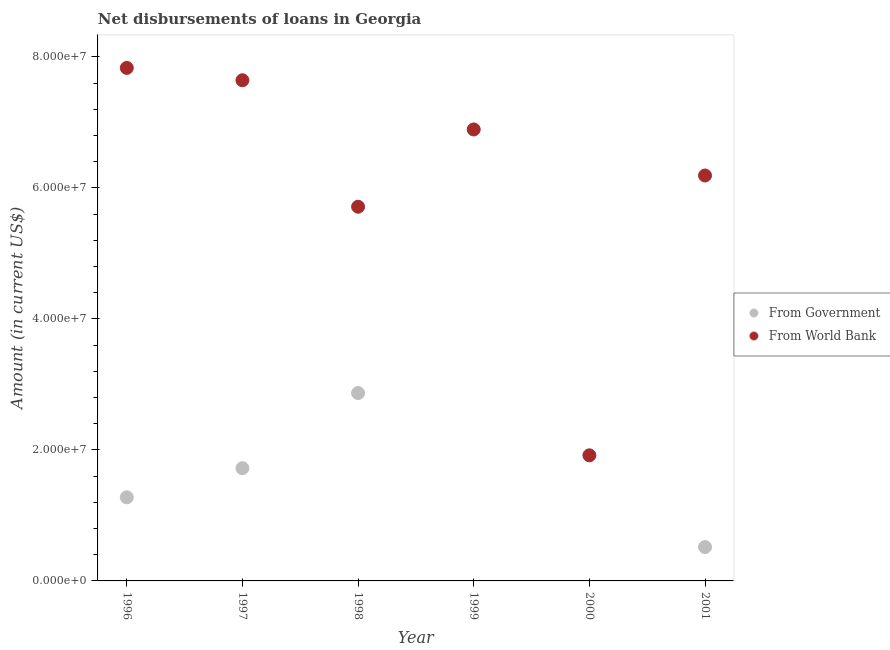How many different coloured dotlines are there?
Your answer should be compact. 2. Is the number of dotlines equal to the number of legend labels?
Offer a terse response. No. What is the net disbursements of loan from government in 1996?
Offer a terse response. 1.28e+07. Across all years, what is the maximum net disbursements of loan from government?
Offer a terse response. 2.87e+07. Across all years, what is the minimum net disbursements of loan from world bank?
Ensure brevity in your answer.  1.92e+07. What is the total net disbursements of loan from government in the graph?
Keep it short and to the point. 6.38e+07. What is the difference between the net disbursements of loan from world bank in 1996 and that in 2000?
Give a very brief answer. 5.91e+07. What is the difference between the net disbursements of loan from government in 1997 and the net disbursements of loan from world bank in 1996?
Provide a short and direct response. -6.11e+07. What is the average net disbursements of loan from world bank per year?
Keep it short and to the point. 6.03e+07. In the year 1998, what is the difference between the net disbursements of loan from world bank and net disbursements of loan from government?
Provide a succinct answer. 2.84e+07. In how many years, is the net disbursements of loan from government greater than 16000000 US$?
Ensure brevity in your answer.  2. What is the ratio of the net disbursements of loan from government in 1998 to that in 2001?
Make the answer very short. 5.55. What is the difference between the highest and the second highest net disbursements of loan from world bank?
Keep it short and to the point. 1.88e+06. What is the difference between the highest and the lowest net disbursements of loan from world bank?
Provide a succinct answer. 5.91e+07. Is the net disbursements of loan from government strictly greater than the net disbursements of loan from world bank over the years?
Ensure brevity in your answer.  No. Is the net disbursements of loan from government strictly less than the net disbursements of loan from world bank over the years?
Offer a terse response. Yes. How many years are there in the graph?
Provide a succinct answer. 6. Are the values on the major ticks of Y-axis written in scientific E-notation?
Give a very brief answer. Yes. What is the title of the graph?
Your answer should be very brief. Net disbursements of loans in Georgia. What is the label or title of the X-axis?
Your answer should be very brief. Year. What is the label or title of the Y-axis?
Your answer should be compact. Amount (in current US$). What is the Amount (in current US$) in From Government in 1996?
Provide a short and direct response. 1.28e+07. What is the Amount (in current US$) of From World Bank in 1996?
Your answer should be compact. 7.83e+07. What is the Amount (in current US$) in From Government in 1997?
Offer a terse response. 1.72e+07. What is the Amount (in current US$) of From World Bank in 1997?
Your response must be concise. 7.64e+07. What is the Amount (in current US$) in From Government in 1998?
Give a very brief answer. 2.87e+07. What is the Amount (in current US$) in From World Bank in 1998?
Offer a terse response. 5.71e+07. What is the Amount (in current US$) of From Government in 1999?
Give a very brief answer. 0. What is the Amount (in current US$) in From World Bank in 1999?
Offer a terse response. 6.89e+07. What is the Amount (in current US$) of From Government in 2000?
Offer a very short reply. 0. What is the Amount (in current US$) of From World Bank in 2000?
Offer a terse response. 1.92e+07. What is the Amount (in current US$) in From Government in 2001?
Offer a very short reply. 5.17e+06. What is the Amount (in current US$) in From World Bank in 2001?
Keep it short and to the point. 6.19e+07. Across all years, what is the maximum Amount (in current US$) of From Government?
Make the answer very short. 2.87e+07. Across all years, what is the maximum Amount (in current US$) of From World Bank?
Offer a very short reply. 7.83e+07. Across all years, what is the minimum Amount (in current US$) of From World Bank?
Keep it short and to the point. 1.92e+07. What is the total Amount (in current US$) in From Government in the graph?
Keep it short and to the point. 6.38e+07. What is the total Amount (in current US$) of From World Bank in the graph?
Provide a succinct answer. 3.62e+08. What is the difference between the Amount (in current US$) of From Government in 1996 and that in 1997?
Make the answer very short. -4.45e+06. What is the difference between the Amount (in current US$) of From World Bank in 1996 and that in 1997?
Provide a succinct answer. 1.88e+06. What is the difference between the Amount (in current US$) in From Government in 1996 and that in 1998?
Provide a succinct answer. -1.59e+07. What is the difference between the Amount (in current US$) of From World Bank in 1996 and that in 1998?
Give a very brief answer. 2.12e+07. What is the difference between the Amount (in current US$) in From World Bank in 1996 and that in 1999?
Your answer should be compact. 9.40e+06. What is the difference between the Amount (in current US$) in From World Bank in 1996 and that in 2000?
Keep it short and to the point. 5.91e+07. What is the difference between the Amount (in current US$) of From Government in 1996 and that in 2001?
Offer a terse response. 7.59e+06. What is the difference between the Amount (in current US$) of From World Bank in 1996 and that in 2001?
Keep it short and to the point. 1.64e+07. What is the difference between the Amount (in current US$) in From Government in 1997 and that in 1998?
Your response must be concise. -1.15e+07. What is the difference between the Amount (in current US$) in From World Bank in 1997 and that in 1998?
Make the answer very short. 1.93e+07. What is the difference between the Amount (in current US$) of From World Bank in 1997 and that in 1999?
Make the answer very short. 7.51e+06. What is the difference between the Amount (in current US$) in From World Bank in 1997 and that in 2000?
Give a very brief answer. 5.73e+07. What is the difference between the Amount (in current US$) of From Government in 1997 and that in 2001?
Give a very brief answer. 1.20e+07. What is the difference between the Amount (in current US$) in From World Bank in 1997 and that in 2001?
Provide a short and direct response. 1.45e+07. What is the difference between the Amount (in current US$) of From World Bank in 1998 and that in 1999?
Your response must be concise. -1.18e+07. What is the difference between the Amount (in current US$) of From World Bank in 1998 and that in 2000?
Ensure brevity in your answer.  3.80e+07. What is the difference between the Amount (in current US$) in From Government in 1998 and that in 2001?
Provide a short and direct response. 2.35e+07. What is the difference between the Amount (in current US$) in From World Bank in 1998 and that in 2001?
Make the answer very short. -4.77e+06. What is the difference between the Amount (in current US$) of From World Bank in 1999 and that in 2000?
Provide a short and direct response. 4.98e+07. What is the difference between the Amount (in current US$) in From World Bank in 1999 and that in 2001?
Offer a very short reply. 7.03e+06. What is the difference between the Amount (in current US$) in From World Bank in 2000 and that in 2001?
Keep it short and to the point. -4.27e+07. What is the difference between the Amount (in current US$) of From Government in 1996 and the Amount (in current US$) of From World Bank in 1997?
Ensure brevity in your answer.  -6.37e+07. What is the difference between the Amount (in current US$) in From Government in 1996 and the Amount (in current US$) in From World Bank in 1998?
Offer a very short reply. -4.44e+07. What is the difference between the Amount (in current US$) in From Government in 1996 and the Amount (in current US$) in From World Bank in 1999?
Provide a succinct answer. -5.62e+07. What is the difference between the Amount (in current US$) of From Government in 1996 and the Amount (in current US$) of From World Bank in 2000?
Your answer should be very brief. -6.42e+06. What is the difference between the Amount (in current US$) in From Government in 1996 and the Amount (in current US$) in From World Bank in 2001?
Give a very brief answer. -4.91e+07. What is the difference between the Amount (in current US$) of From Government in 1997 and the Amount (in current US$) of From World Bank in 1998?
Provide a succinct answer. -3.99e+07. What is the difference between the Amount (in current US$) in From Government in 1997 and the Amount (in current US$) in From World Bank in 1999?
Your response must be concise. -5.17e+07. What is the difference between the Amount (in current US$) in From Government in 1997 and the Amount (in current US$) in From World Bank in 2000?
Offer a very short reply. -1.96e+06. What is the difference between the Amount (in current US$) in From Government in 1997 and the Amount (in current US$) in From World Bank in 2001?
Your answer should be compact. -4.47e+07. What is the difference between the Amount (in current US$) of From Government in 1998 and the Amount (in current US$) of From World Bank in 1999?
Keep it short and to the point. -4.02e+07. What is the difference between the Amount (in current US$) in From Government in 1998 and the Amount (in current US$) in From World Bank in 2000?
Your answer should be compact. 9.51e+06. What is the difference between the Amount (in current US$) of From Government in 1998 and the Amount (in current US$) of From World Bank in 2001?
Provide a short and direct response. -3.32e+07. What is the average Amount (in current US$) of From Government per year?
Your response must be concise. 1.06e+07. What is the average Amount (in current US$) in From World Bank per year?
Ensure brevity in your answer.  6.03e+07. In the year 1996, what is the difference between the Amount (in current US$) of From Government and Amount (in current US$) of From World Bank?
Ensure brevity in your answer.  -6.56e+07. In the year 1997, what is the difference between the Amount (in current US$) of From Government and Amount (in current US$) of From World Bank?
Give a very brief answer. -5.92e+07. In the year 1998, what is the difference between the Amount (in current US$) in From Government and Amount (in current US$) in From World Bank?
Offer a terse response. -2.84e+07. In the year 2001, what is the difference between the Amount (in current US$) in From Government and Amount (in current US$) in From World Bank?
Offer a very short reply. -5.67e+07. What is the ratio of the Amount (in current US$) in From Government in 1996 to that in 1997?
Give a very brief answer. 0.74. What is the ratio of the Amount (in current US$) of From World Bank in 1996 to that in 1997?
Give a very brief answer. 1.02. What is the ratio of the Amount (in current US$) of From Government in 1996 to that in 1998?
Your response must be concise. 0.45. What is the ratio of the Amount (in current US$) in From World Bank in 1996 to that in 1998?
Provide a succinct answer. 1.37. What is the ratio of the Amount (in current US$) of From World Bank in 1996 to that in 1999?
Offer a very short reply. 1.14. What is the ratio of the Amount (in current US$) of From World Bank in 1996 to that in 2000?
Keep it short and to the point. 4.08. What is the ratio of the Amount (in current US$) in From Government in 1996 to that in 2001?
Give a very brief answer. 2.47. What is the ratio of the Amount (in current US$) in From World Bank in 1996 to that in 2001?
Make the answer very short. 1.27. What is the ratio of the Amount (in current US$) of From Government in 1997 to that in 1998?
Provide a succinct answer. 0.6. What is the ratio of the Amount (in current US$) in From World Bank in 1997 to that in 1998?
Offer a very short reply. 1.34. What is the ratio of the Amount (in current US$) of From World Bank in 1997 to that in 1999?
Your response must be concise. 1.11. What is the ratio of the Amount (in current US$) in From World Bank in 1997 to that in 2000?
Ensure brevity in your answer.  3.99. What is the ratio of the Amount (in current US$) of From Government in 1997 to that in 2001?
Your answer should be very brief. 3.33. What is the ratio of the Amount (in current US$) in From World Bank in 1997 to that in 2001?
Offer a terse response. 1.24. What is the ratio of the Amount (in current US$) of From World Bank in 1998 to that in 1999?
Keep it short and to the point. 0.83. What is the ratio of the Amount (in current US$) of From World Bank in 1998 to that in 2000?
Your response must be concise. 2.98. What is the ratio of the Amount (in current US$) in From Government in 1998 to that in 2001?
Make the answer very short. 5.55. What is the ratio of the Amount (in current US$) in From World Bank in 1998 to that in 2001?
Offer a terse response. 0.92. What is the ratio of the Amount (in current US$) of From World Bank in 1999 to that in 2000?
Give a very brief answer. 3.59. What is the ratio of the Amount (in current US$) of From World Bank in 1999 to that in 2001?
Offer a terse response. 1.11. What is the ratio of the Amount (in current US$) of From World Bank in 2000 to that in 2001?
Ensure brevity in your answer.  0.31. What is the difference between the highest and the second highest Amount (in current US$) of From Government?
Make the answer very short. 1.15e+07. What is the difference between the highest and the second highest Amount (in current US$) in From World Bank?
Provide a succinct answer. 1.88e+06. What is the difference between the highest and the lowest Amount (in current US$) in From Government?
Give a very brief answer. 2.87e+07. What is the difference between the highest and the lowest Amount (in current US$) of From World Bank?
Make the answer very short. 5.91e+07. 